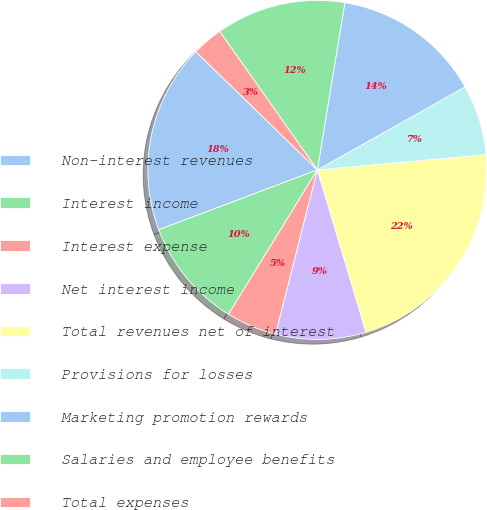Convert chart to OTSL. <chart><loc_0><loc_0><loc_500><loc_500><pie_chart><fcel>Non-interest revenues<fcel>Interest income<fcel>Interest expense<fcel>Net interest income<fcel>Total revenues net of interest<fcel>Provisions for losses<fcel>Marketing promotion rewards<fcel>Salaries and employee benefits<fcel>Total expenses<nl><fcel>18.03%<fcel>10.48%<fcel>4.82%<fcel>8.6%<fcel>21.8%<fcel>6.71%<fcel>14.26%<fcel>12.37%<fcel>2.94%<nl></chart> 